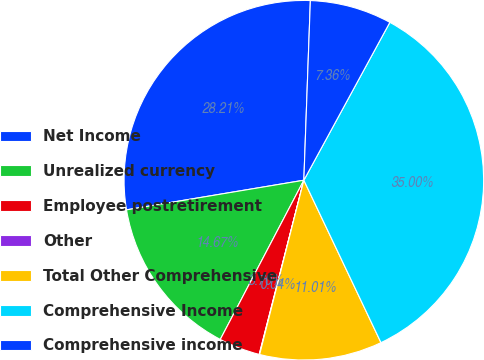Convert chart. <chart><loc_0><loc_0><loc_500><loc_500><pie_chart><fcel>Net Income<fcel>Unrealized currency<fcel>Employee postretirement<fcel>Other<fcel>Total Other Comprehensive<fcel>Comprehensive Income<fcel>Comprehensive income<nl><fcel>28.21%<fcel>14.67%<fcel>3.7%<fcel>0.04%<fcel>11.01%<fcel>35.0%<fcel>7.36%<nl></chart> 